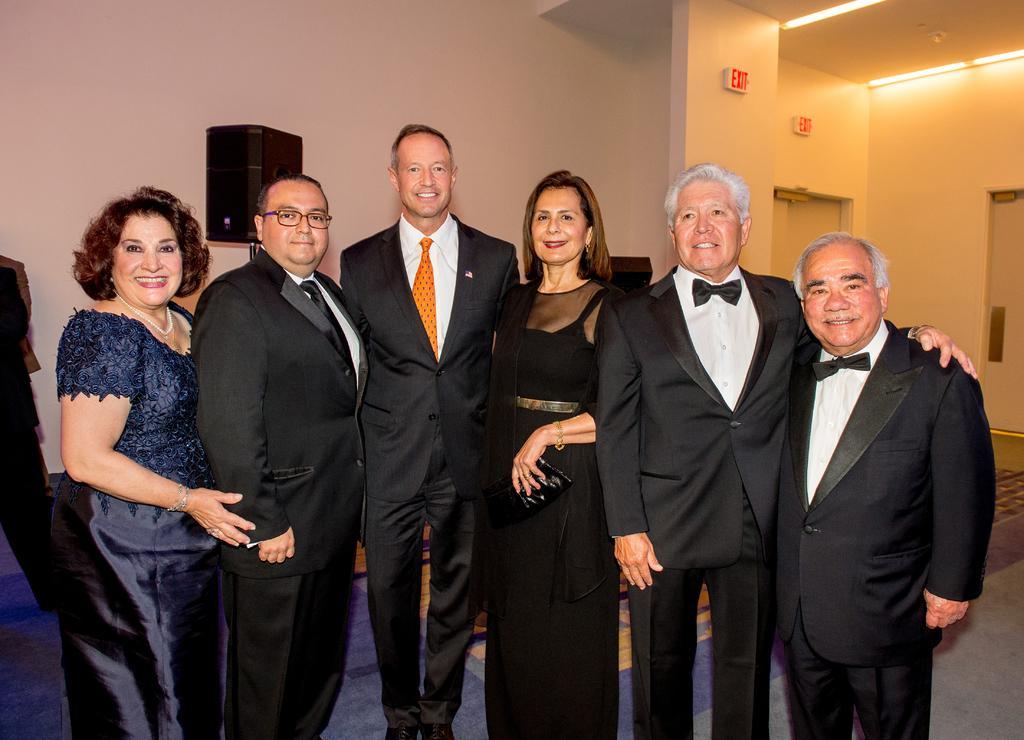How would you summarize this image in a sentence or two? In the center of the image we can see people standing and smiling. In the background there is a wall and there are doors. We can see a speaker. At the top there are lights. 